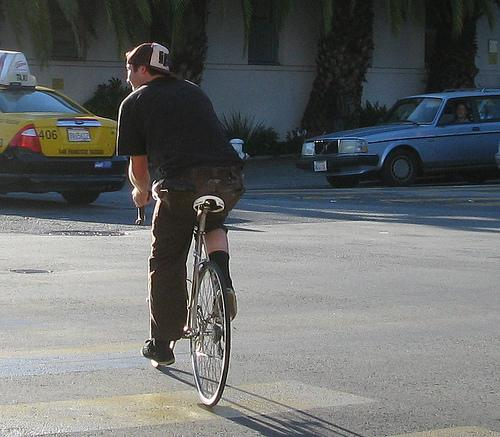Identify the primary object in motion and describe its activity. A guy riding a bicycle on the street, pedaling and maintaining balance with his body upright. What type of vehicle is parked closest to the center of the intersection and what color is it? A light blue car is parked closest to the center of the intersection. List three objects that are not vehicles that can be found near the edge of the road. A white fire hydrant, a round metal manhole cover, and a tree trunk. What type of object can be seen creating a shadow on the pavement and how large is the shadow area? A shadow of a bicycle on the pavement, measuring 135 pixels in width and height. Identify an object in the photo that indicates the presence of a bicycle, and describe its function. Bicycle wheel spokes, which provide support and stability to the bicycle wheel. Explain what the pedestrian in the image is doing and describe their clothing. A man is riding a bike on the street, wearing a black shirt, black socks, and a brown and white cap. In the context of the image, describe the position and color of a fire hydrant. A white fire hydrant is located alongside the road near the sidewalk. What is the prominent accessory or article of clothing on the person riding the bicycle, and what color is it? A brown and white cap being worn backwards on the person's head. Provide a brief description of one of the cars in the image, and mention any distinctive features. A yellow taxi cab with a mounted car top sign, headlights, a grill, and a license plate on the back. Describe the visual content related to a person operating a vehicle within the image. A man driving a car wearing a cap backwards, with sun on his face, and wearing a black shirt. 